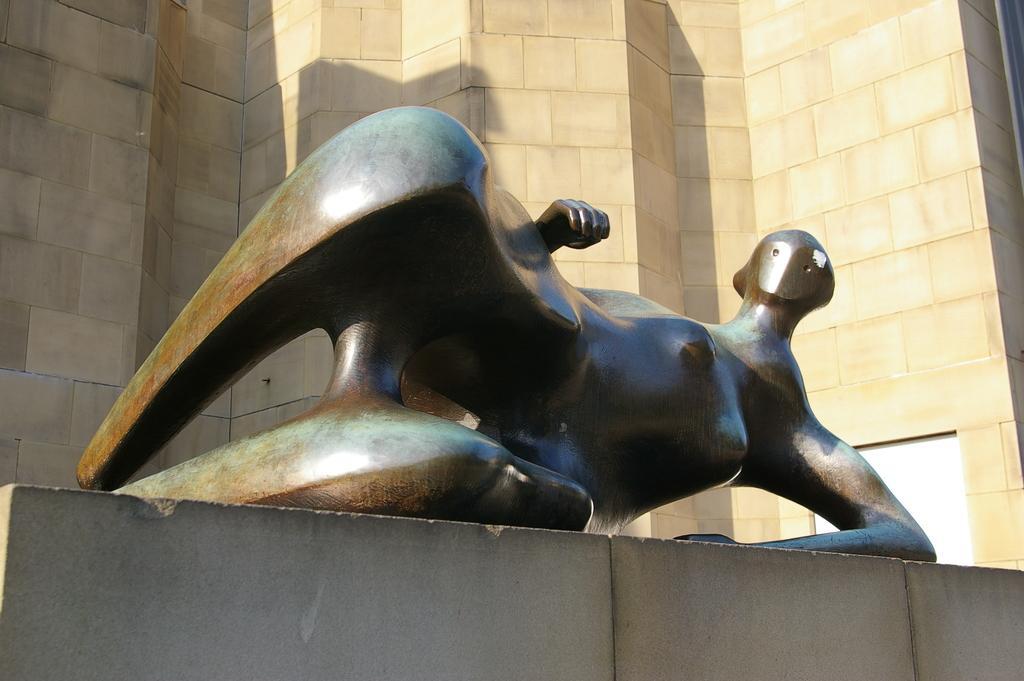How would you summarize this image in a sentence or two? In this picture I can see there is a statue lying here on the base and in the backdrop I can see there is a wall. 